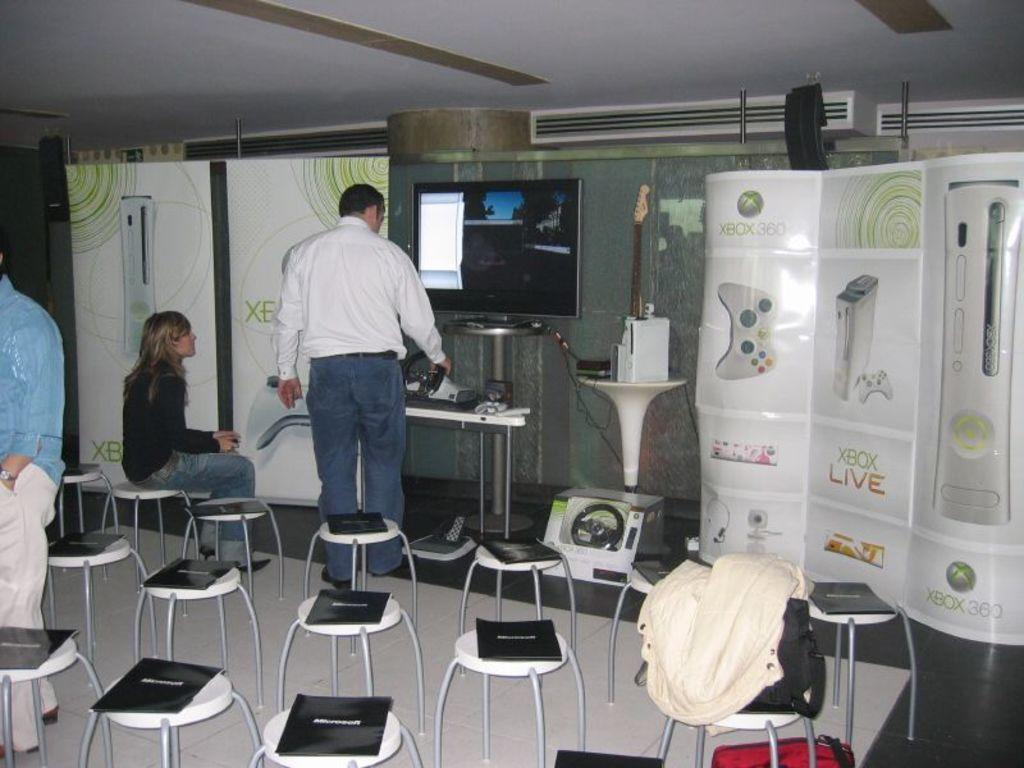Provide a one-sentence caption for the provided image. A seminar or gamer test for Xbox Live. 